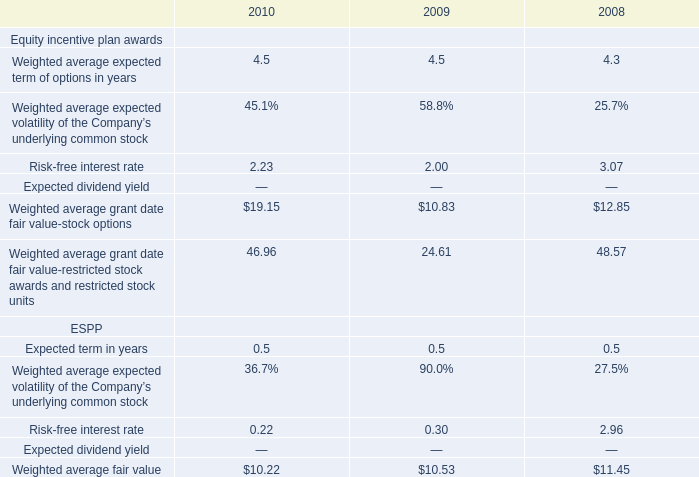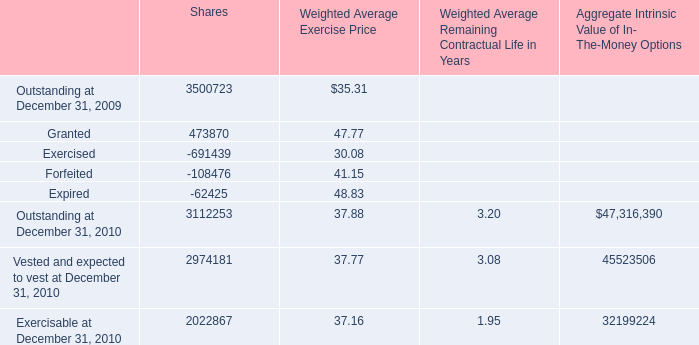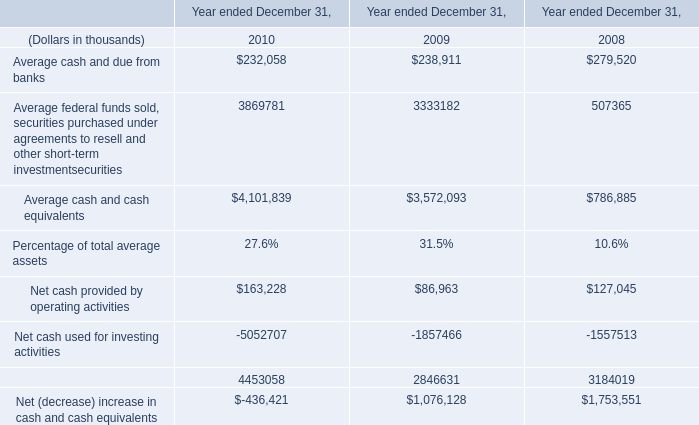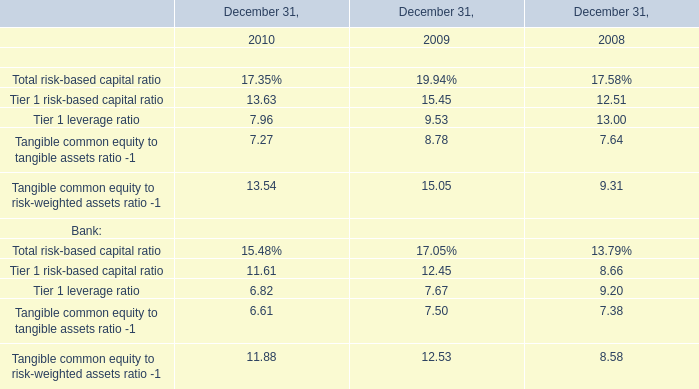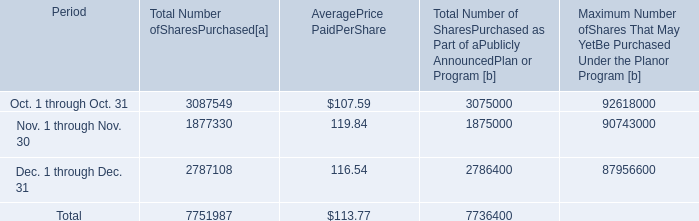what wa the total spent on share repurchases during 2014? 
Computations: (33035204 * 100.24)
Answer: 3311448848.96. 